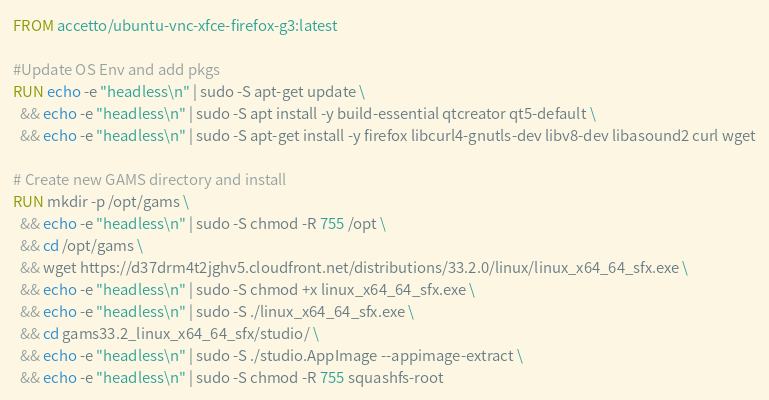<code> <loc_0><loc_0><loc_500><loc_500><_Dockerfile_>FROM accetto/ubuntu-vnc-xfce-firefox-g3:latest

#Update OS Env and add pkgs
RUN echo -e "headless\n" | sudo -S apt-get update \
  && echo -e "headless\n" | sudo -S apt install -y build-essential qtcreator qt5-default \
  && echo -e "headless\n" | sudo -S apt-get install -y firefox libcurl4-gnutls-dev libv8-dev libasound2 curl wget
  
# Create new GAMS directory and install
RUN mkdir -p /opt/gams \
  && echo -e "headless\n" | sudo -S chmod -R 755 /opt \
  && cd /opt/gams \
  && wget https://d37drm4t2jghv5.cloudfront.net/distributions/33.2.0/linux/linux_x64_64_sfx.exe \
  && echo -e "headless\n" | sudo -S chmod +x linux_x64_64_sfx.exe \
  && echo -e "headless\n" | sudo -S ./linux_x64_64_sfx.exe \
  && cd gams33.2_linux_x64_64_sfx/studio/ \
  && echo -e "headless\n" | sudo -S ./studio.AppImage --appimage-extract \
  && echo -e "headless\n" | sudo -S chmod -R 755 squashfs-root
</code> 